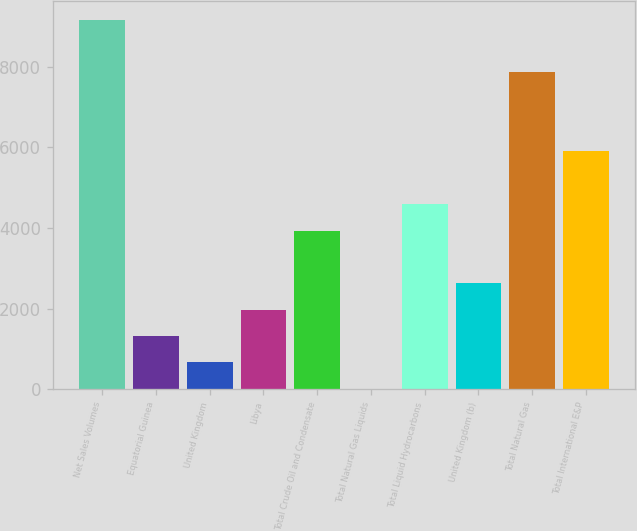Convert chart. <chart><loc_0><loc_0><loc_500><loc_500><bar_chart><fcel>Net Sales Volumes<fcel>Equatorial Guinea<fcel>United Kingdom<fcel>Libya<fcel>Total Crude Oil and Condensate<fcel>Total Natural Gas Liquids<fcel>Total Liquid Hydrocarbons<fcel>United Kingdom (b)<fcel>Total Natural Gas<fcel>Total International E&P<nl><fcel>9162.4<fcel>1319.2<fcel>665.6<fcel>1972.8<fcel>3933.6<fcel>12<fcel>4587.2<fcel>2626.4<fcel>7855.2<fcel>5894.4<nl></chart> 